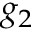Convert formula to latex. <formula><loc_0><loc_0><loc_500><loc_500>g _ { 2 }</formula> 